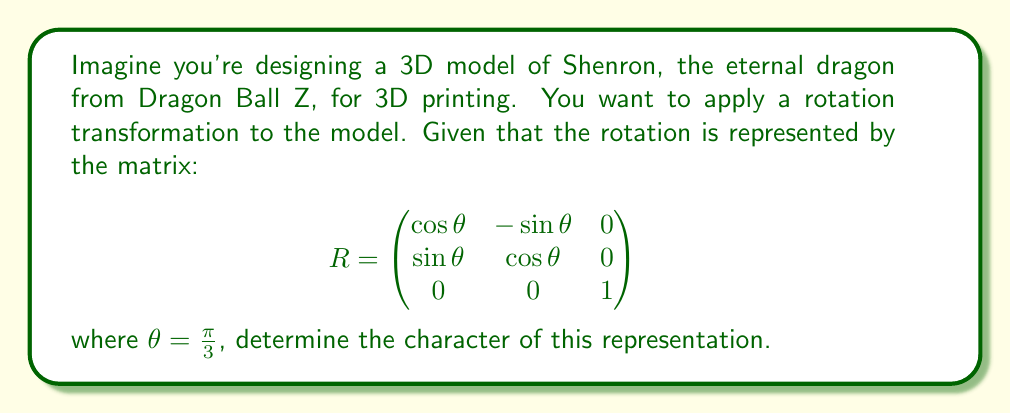What is the answer to this math problem? To find the character of this representation, we need to follow these steps:

1) The character of a representation is defined as the trace of the matrix representing the transformation. The trace is the sum of the elements on the main diagonal of the matrix.

2) For our rotation matrix $R$, we have:

   $$R = \begin{pmatrix}
   \cos(\frac{\pi}{3}) & -\sin(\frac{\pi}{3}) & 0 \\
   \sin(\frac{\pi}{3}) & \cos(\frac{\pi}{3}) & 0 \\
   0 & 0 & 1
   \end{pmatrix}$$

3) We know that:
   $\cos(\frac{\pi}{3}) = \frac{1}{2}$
   $\sin(\frac{\pi}{3}) = \frac{\sqrt{3}}{2}$

4) Substituting these values:

   $$R = \begin{pmatrix}
   \frac{1}{2} & -\frac{\sqrt{3}}{2} & 0 \\
   \frac{\sqrt{3}}{2} & \frac{1}{2} & 0 \\
   0 & 0 & 1
   \end{pmatrix}$$

5) The trace of this matrix is the sum of the elements on the main diagonal:

   $\text{Tr}(R) = \frac{1}{2} + \frac{1}{2} + 1 = 2$

6) Therefore, the character of this representation is 2.
Answer: 2 